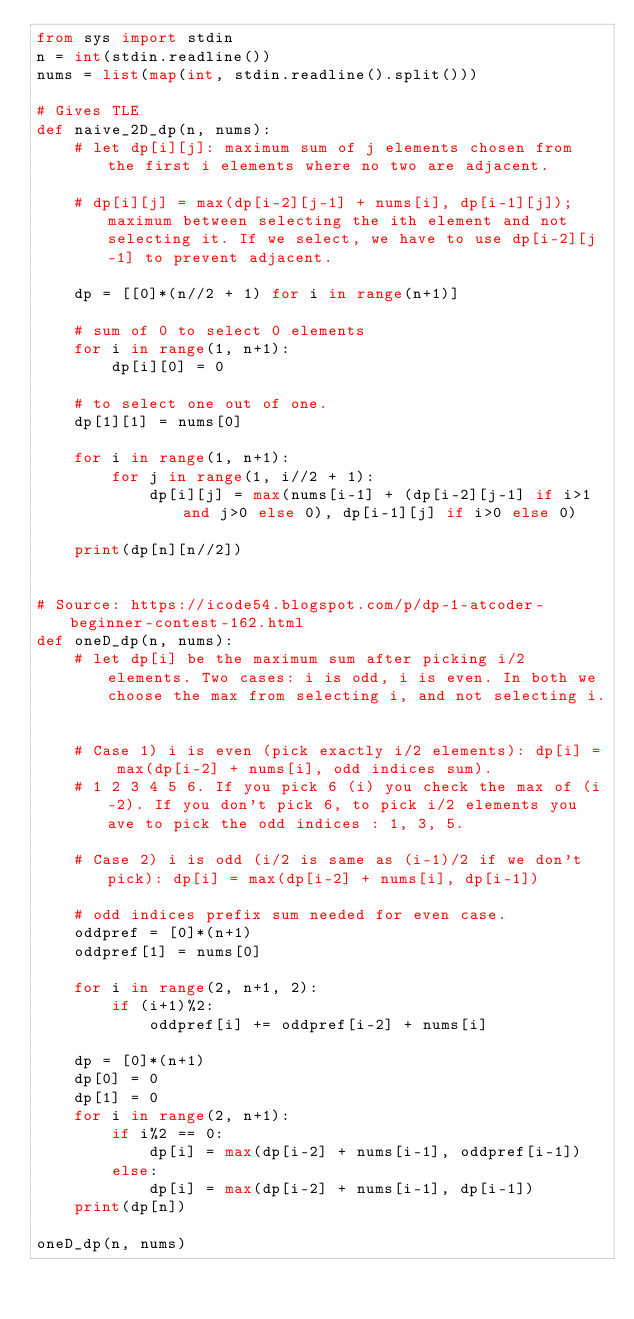Convert code to text. <code><loc_0><loc_0><loc_500><loc_500><_Python_>from sys import stdin
n = int(stdin.readline())
nums = list(map(int, stdin.readline().split()))

# Gives TLE
def naive_2D_dp(n, nums):
    # let dp[i][j]: maximum sum of j elements chosen from the first i elements where no two are adjacent.

    # dp[i][j] = max(dp[i-2][j-1] + nums[i], dp[i-1][j]); maximum between selecting the ith element and not selecting it. If we select, we have to use dp[i-2][j-1] to prevent adjacent.

    dp = [[0]*(n//2 + 1) for i in range(n+1)]

    # sum of 0 to select 0 elements
    for i in range(1, n+1):
        dp[i][0] = 0

    # to select one out of one.
    dp[1][1] = nums[0]

    for i in range(1, n+1):
        for j in range(1, i//2 + 1):
            dp[i][j] = max(nums[i-1] + (dp[i-2][j-1] if i>1 and j>0 else 0), dp[i-1][j] if i>0 else 0)

    print(dp[n][n//2])


# Source: https://icode54.blogspot.com/p/dp-1-atcoder-beginner-contest-162.html
def oneD_dp(n, nums):
    # let dp[i] be the maximum sum after picking i/2 elements. Two cases: i is odd, i is even. In both we choose the max from selecting i, and not selecting i.


    # Case 1) i is even (pick exactly i/2 elements): dp[i] = max(dp[i-2] + nums[i], odd indices sum). 
    # 1 2 3 4 5 6. If you pick 6 (i) you check the max of (i-2). If you don't pick 6, to pick i/2 elements you ave to pick the odd indices : 1, 3, 5.

    # Case 2) i is odd (i/2 is same as (i-1)/2 if we don't pick): dp[i] = max(dp[i-2] + nums[i], dp[i-1])

    # odd indices prefix sum needed for even case.
    oddpref = [0]*(n+1)
    oddpref[1] = nums[0]

    for i in range(2, n+1, 2):
        if (i+1)%2:
            oddpref[i] += oddpref[i-2] + nums[i]
    
    dp = [0]*(n+1)
    dp[0] = 0
    dp[1] = 0
    for i in range(2, n+1):
        if i%2 == 0:
            dp[i] = max(dp[i-2] + nums[i-1], oddpref[i-1])
        else:
            dp[i] = max(dp[i-2] + nums[i-1], dp[i-1])
    print(dp[n])

oneD_dp(n, nums)</code> 